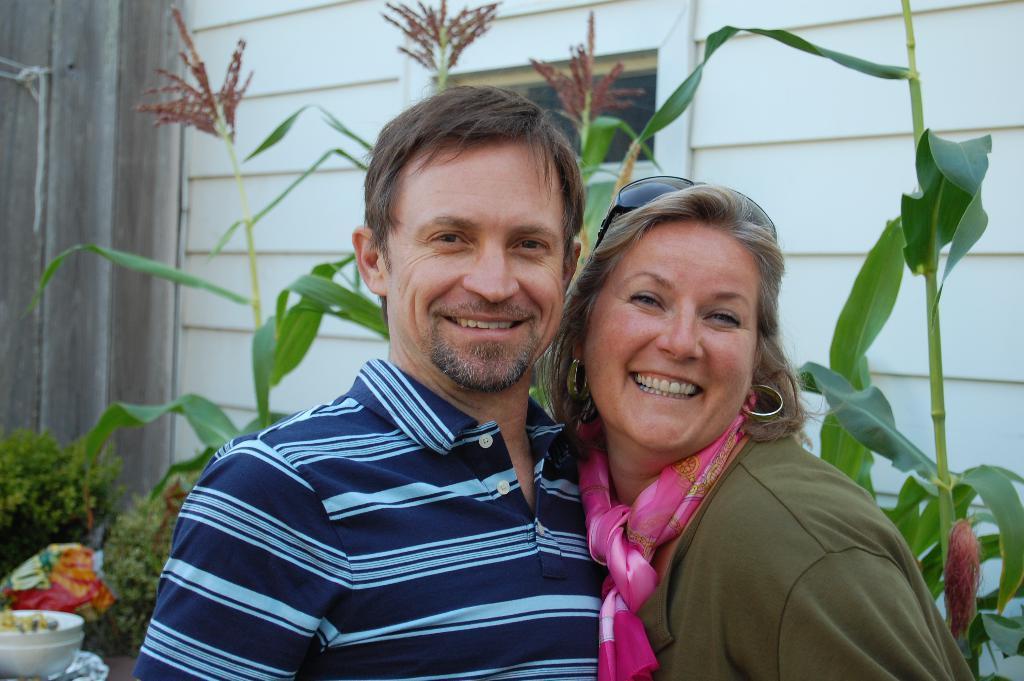In one or two sentences, can you explain what this image depicts? In the left side a man is smiling, he wore a t-shirt, beside him there is a woman is also smiling. Behind them there are plants. 